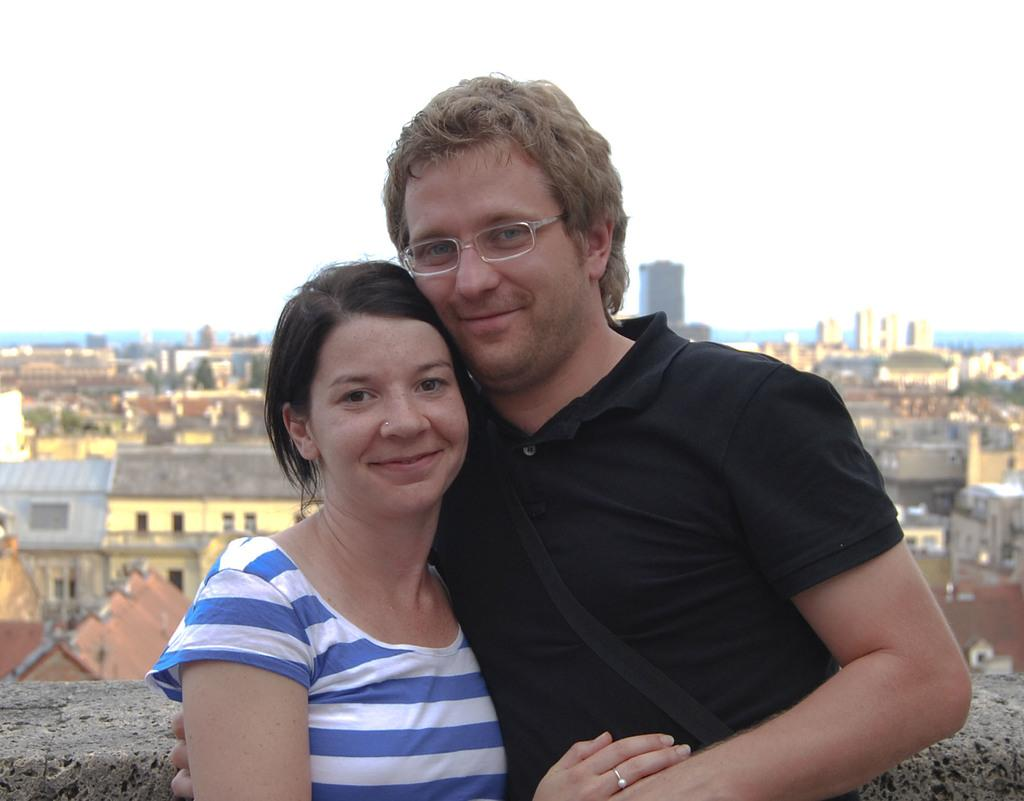How many people are present in the image? There are two people, a man and a woman, present in the image. What are the man and woman doing in the image? The man and woman are standing. What can be seen in the background of the image? There are houses and the sky visible in the background of the image. What type of sidewalk can be seen in the image? There is no sidewalk present in the image. Is the writer in the image working on their latest novel? There is no writer present in the image. 